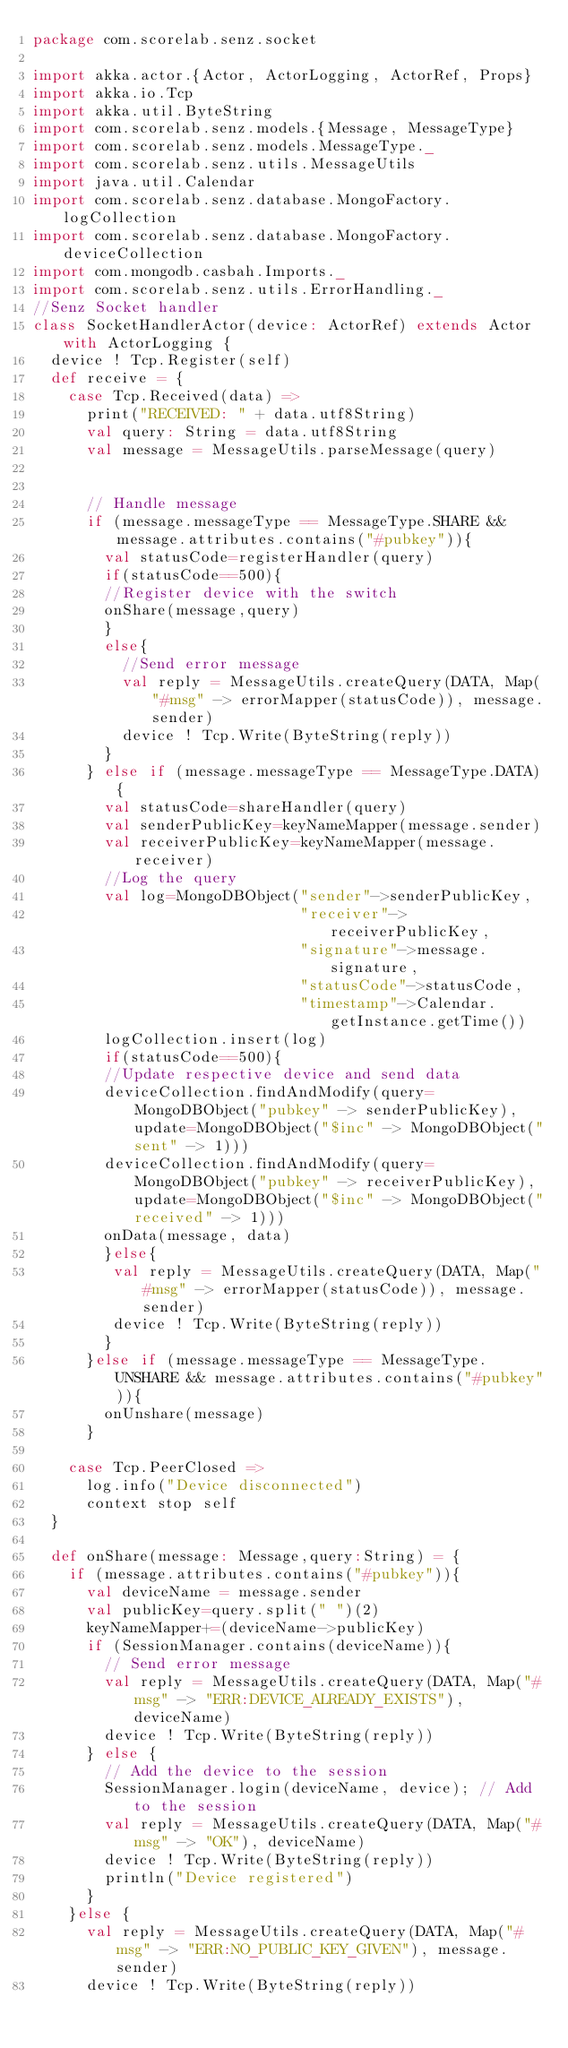Convert code to text. <code><loc_0><loc_0><loc_500><loc_500><_Scala_>package com.scorelab.senz.socket

import akka.actor.{Actor, ActorLogging, ActorRef, Props}
import akka.io.Tcp
import akka.util.ByteString
import com.scorelab.senz.models.{Message, MessageType}
import com.scorelab.senz.models.MessageType._
import com.scorelab.senz.utils.MessageUtils
import java.util.Calendar
import com.scorelab.senz.database.MongoFactory.logCollection
import com.scorelab.senz.database.MongoFactory.deviceCollection
import com.mongodb.casbah.Imports._
import com.scorelab.senz.utils.ErrorHandling._
//Senz Socket handler
class SocketHandlerActor(device: ActorRef) extends Actor with ActorLogging {
  device ! Tcp.Register(self)
  def receive = {
    case Tcp.Received(data) =>
      print("RECEIVED: " + data.utf8String)
      val query: String = data.utf8String
      val message = MessageUtils.parseMessage(query)


      // Handle message
      if (message.messageType == MessageType.SHARE && message.attributes.contains("#pubkey")){
        val statusCode=registerHandler(query)
        if(statusCode==500){
        //Register device with the switch
        onShare(message,query)
        }
        else{
          //Send error message
          val reply = MessageUtils.createQuery(DATA, Map("#msg" -> errorMapper(statusCode)), message.sender)
          device ! Tcp.Write(ByteString(reply))
        }
      } else if (message.messageType == MessageType.DATA){ 
        val statusCode=shareHandler(query)
        val senderPublicKey=keyNameMapper(message.sender)
        val receiverPublicKey=keyNameMapper(message.receiver)
        //Log the query
        val log=MongoDBObject("sender"->senderPublicKey,
                              "receiver"->receiverPublicKey,
                              "signature"->message.signature,
                              "statusCode"->statusCode,
                              "timestamp"->Calendar.getInstance.getTime())
        logCollection.insert(log)    
        if(statusCode==500){                  
        //Update respective device and send data
        deviceCollection.findAndModify(query=MongoDBObject("pubkey" -> senderPublicKey),update=MongoDBObject("$inc" -> MongoDBObject("sent" -> 1)))
        deviceCollection.findAndModify(query=MongoDBObject("pubkey" -> receiverPublicKey),update=MongoDBObject("$inc" -> MongoDBObject("received" -> 1)))
        onData(message, data)
        }else{
         val reply = MessageUtils.createQuery(DATA, Map("#msg" -> errorMapper(statusCode)), message.sender)
         device ! Tcp.Write(ByteString(reply))
        }       
      }else if (message.messageType == MessageType.UNSHARE && message.attributes.contains("#pubkey")){
        onUnshare(message)
      }

    case Tcp.PeerClosed =>
      log.info("Device disconnected")
      context stop self
  }

  def onShare(message: Message,query:String) = {
    if (message.attributes.contains("#pubkey")){
      val deviceName = message.sender
      val publicKey=query.split(" ")(2)
      keyNameMapper+=(deviceName->publicKey)
      if (SessionManager.contains(deviceName)){
        // Send error message
        val reply = MessageUtils.createQuery(DATA, Map("#msg" -> "ERR:DEVICE_ALREADY_EXISTS"), deviceName)
        device ! Tcp.Write(ByteString(reply))
      } else {
        // Add the device to the session
        SessionManager.login(deviceName, device); // Add to the session
        val reply = MessageUtils.createQuery(DATA, Map("#msg" -> "OK"), deviceName)
        device ! Tcp.Write(ByteString(reply))
        println("Device registered")
      }
    }else {
      val reply = MessageUtils.createQuery(DATA, Map("#msg" -> "ERR:NO_PUBLIC_KEY_GIVEN"), message.sender)
      device ! Tcp.Write(ByteString(reply))</code> 